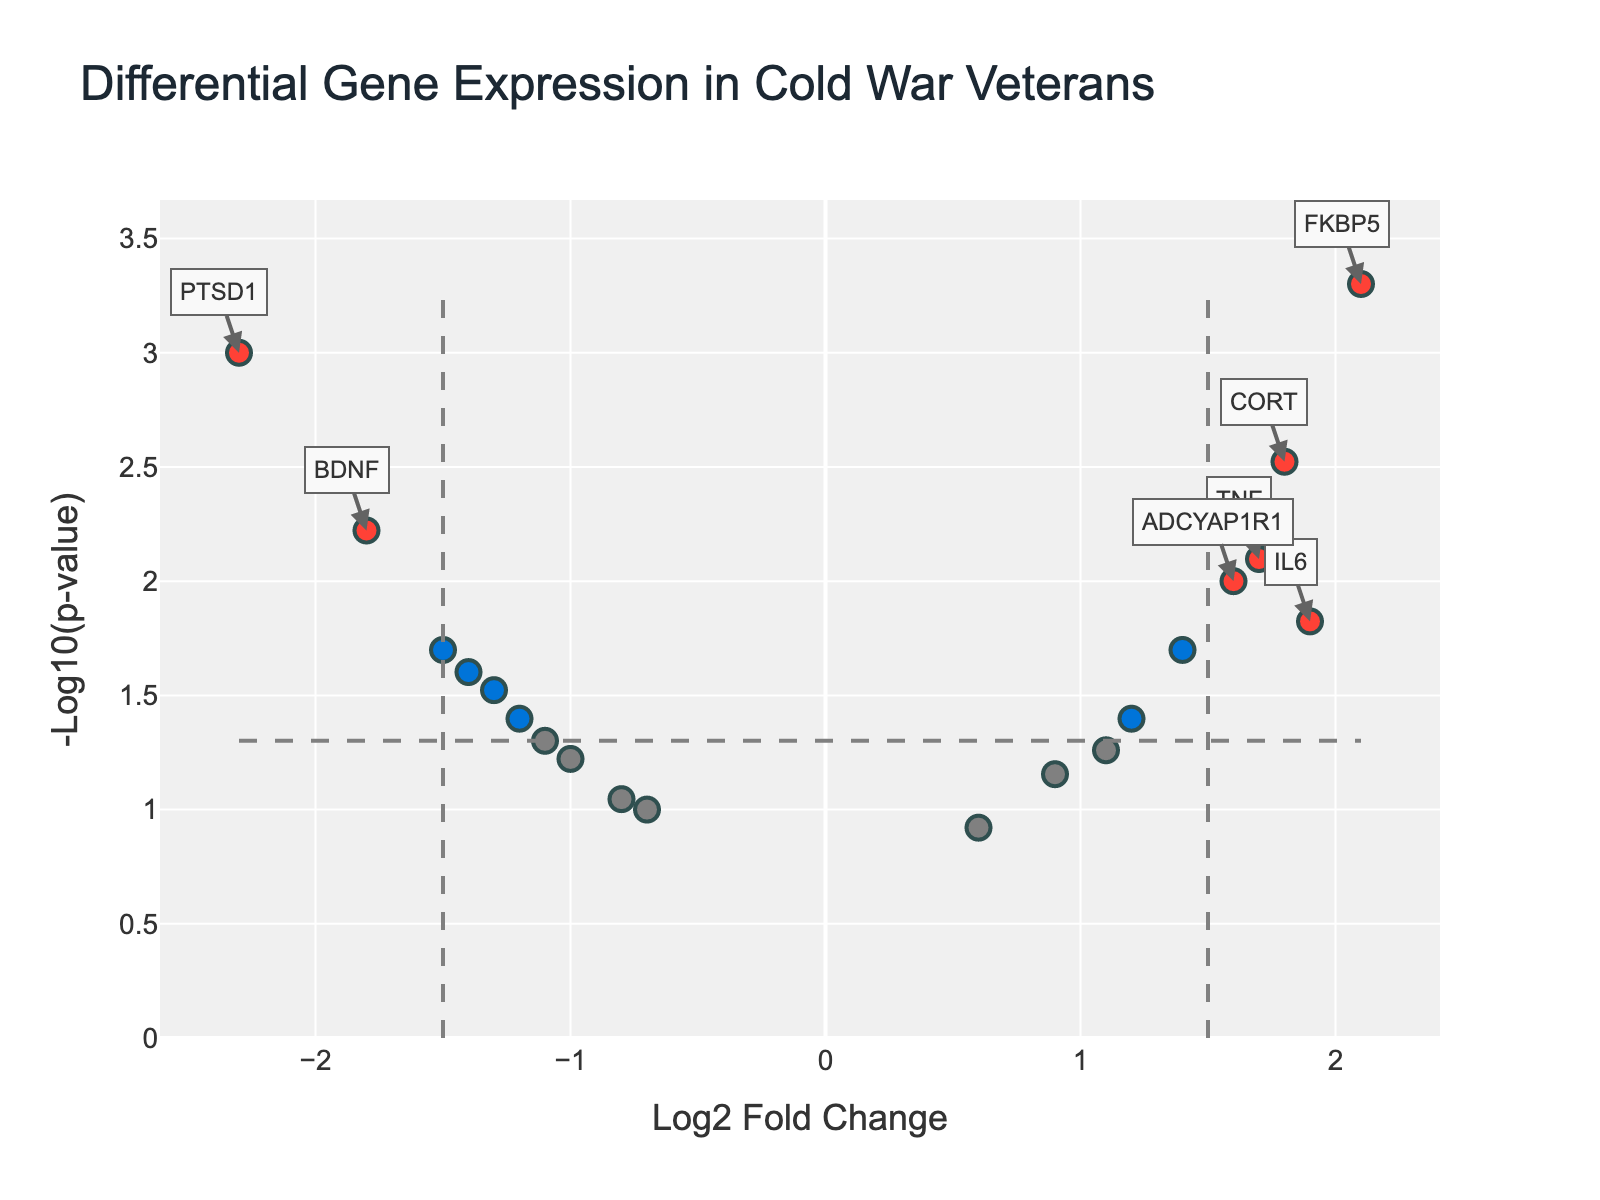What is the title of the plot? The title of the plot is displayed at the top and it provides a summary of what the plot represents.
Answer: Differential Gene Expression in Cold War Veterans What do the x-axis and y-axis represent? The x-axis represents the Log2 Fold Change, while the y-axis represents the -Log10(p-value). These axes indicate the difference in gene expression and the significance of this difference, respectively.
Answer: Log2 Fold Change, -Log10(p-value) How many data points are colored red, and what does this signify? By counting the red data points, you see there are three. The red color indicates that these genes have both a significant fold change (absolute log2FoldChange > 1.5) and a p-value < 0.05.
Answer: Three Which gene has the highest fold change and is significantly different between groups? By observing the genes marked in red and looking at their Log2 Fold Change values, we can see that gene FKBP5 has the highest fold change.
Answer: FKBP5 Are most of the significantly expressed genes upregulated or downregulated? To determine this, count the number of significant genes above (upregulated) and below (downregulated) the x = 0 line. Notice there are more significant genes (red) on the right side (positive Log2 Fold Change) indicating upregulation.
Answer: Upregulated Which is the least significant gene among those colored in blue? Among the blue data points, identify the one with the lowest y-axis value. The gene SLC6A4 has the smallest -Log10(p-value).
Answer: SLC6A4 What can you infer about the gene TPH2 in terms of its expression and significance? The gene TPH2 can be located on the plot and its position shows a Log2 Fold Change of -1.4 and a -Log10(p-value) indicating it is downregulated and statistically significant.
Answer: Downregulated and statistically significant Compare the log2 fold change of CRHR1 and MAOA. Which one has higher expression change? By locating both genes on the x-axis, we observe that CRHR1 has a log2 Fold Change of 1.4 whereas MAOA has a log2 Fold Change of -0.8. Thus, CRHR1 shows a higher expression change.
Answer: CRHR1 What is the significance threshold for p-value in the plot, and how is it illustrated? The p-value significance threshold is shown by a horizontal dashed line at y = -log10(0.05). This threshold helps to visually distinguish statistically significant genes from non-significant ones.
Answer: -log10(0.05) How many genes have p-values greater than 0.05 but fold changes greater than 1.5? To find these, look for green data points which indicate genes that are not significant by p-value but have significant fold changes. There are two such genes.
Answer: Two 